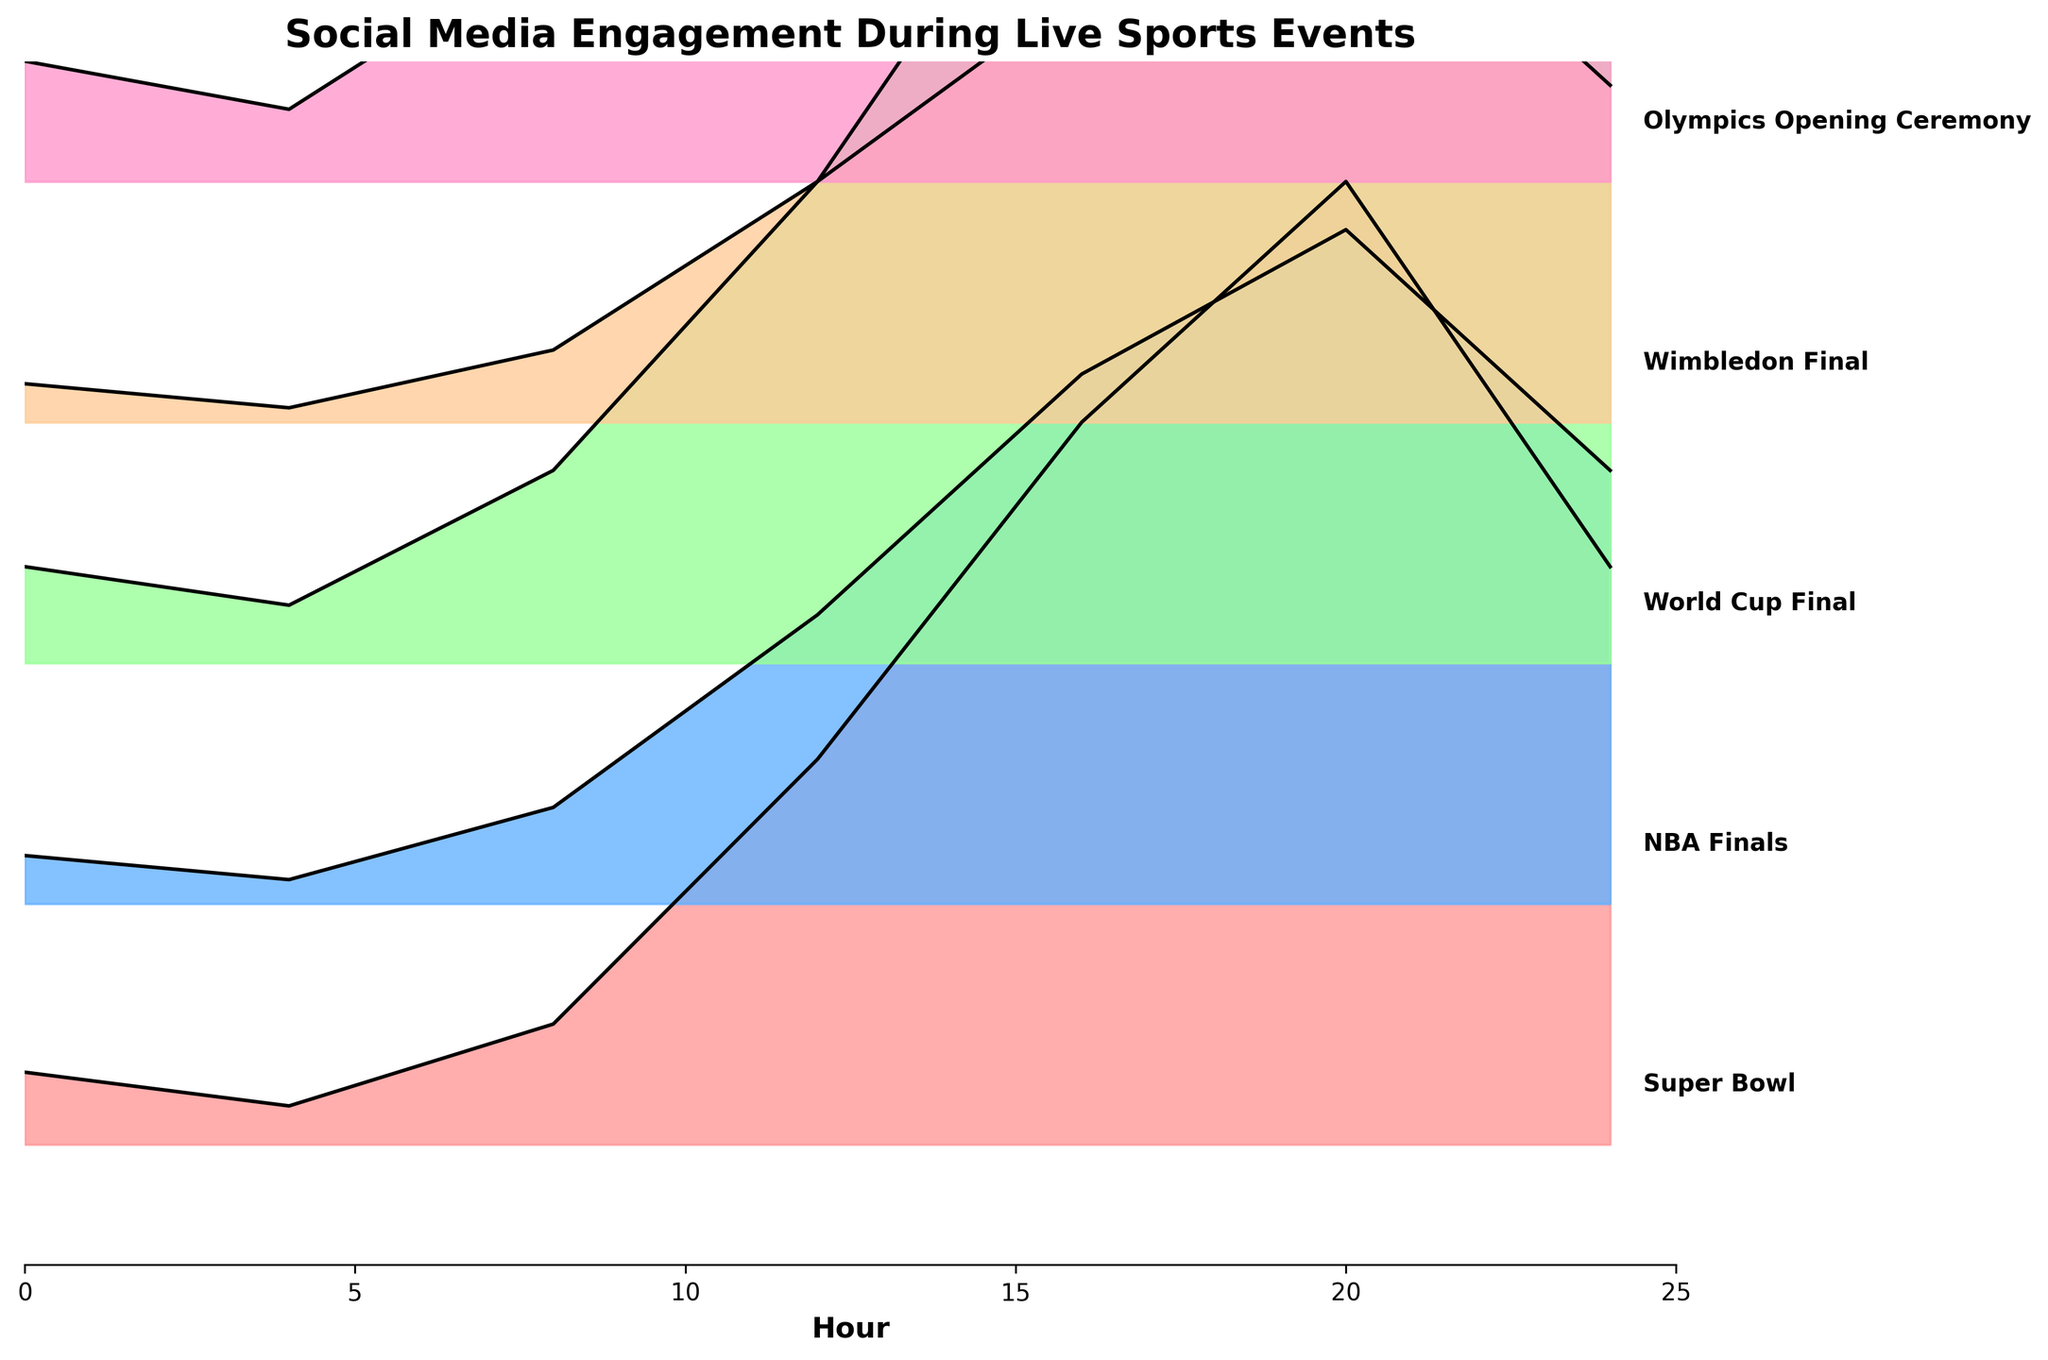What's the title of this figure? The title of a chart is typically located at the top and is clearly set apart from the rest of the content for easy identification. In this figure, it reads 'Social Media Engagement During Live Sports Events.'
Answer: Social Media Engagement During Live Sports Events Which event has the highest engagement peak? To find the highest engagement peak, look at the overall height of the ridgeline peaks for each event. The Olympics Opening Ceremony has the highest peak reaching about 250 units of engagement.
Answer: Olympics Opening Ceremony At what hour does the NBA Finals reach its maximum engagement? By observing the ridgeline for the NBA Finals, the peak engagement appears to occur at the 20th hour.
Answer: 20 Which event shows the least engagement overall at hour 4? To find the event with the least engagement at hour 4, compare the y-values marked on the ridgelines at the 4th hour. The Wimbledon Final has the lowest engagement of 3 units at this hour.
Answer: Wimbledon Final How does the engagement of the Super Bowl compare to the World Cup Final at hour 20? To compare the engagements of both events at hour 20, we look at their respective ridgeline heights at that hour. The Super Bowl has an engagement of 200, whereas the World Cup Final is slightly higher with 220 units.
Answer: World Cup Final is higher What is the average engagement for the Wimbledon Final across all recorded hours? Sum up the engagement values for the Wimbledon Final (8, 3, 15, 50, 90, 120, 70) which total to 356. Divide by the number of data points (7 hours): 356/7 ≈ 51 units.
Answer: Around 51 units Which event shows the steepest increase in engagement from hour 8 to hour 12? The steepest increase is determined by the largest difference between hour 8 and hour 12. The Olympics Opening Ceremony increases from 50 to 120, a difference of 70 units, which is the steepest increase in that range.
Answer: Olympics Opening Ceremony At hour 24, which events show a decrease in engagement compared to hour 20? Compare the engagement at hour 24 against hour 20 for each event. The Super Bowl, NBA Finals, Wimbledon Final, and Olympics Opening Ceremony all show a decrease in engagement from hour 20 to 24.
Answer: Super Bowl, NBA Finals, Wimbledon Final, Olympics Opening Ceremony 